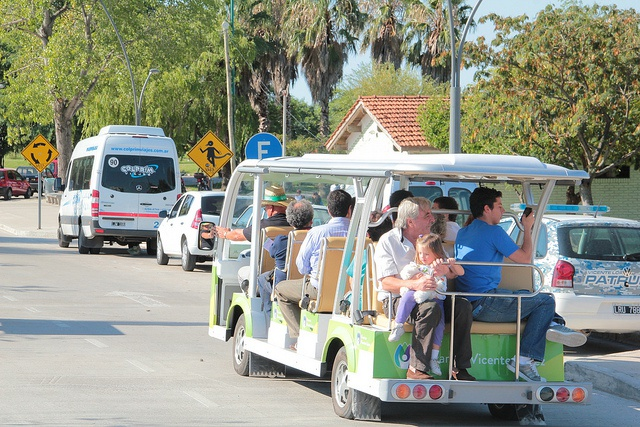Describe the objects in this image and their specific colors. I can see truck in darkgreen, lightblue, white, black, and gray tones, car in darkgreen, darkgray, lightgray, teal, and gray tones, people in darkgreen, blue, navy, and black tones, people in darkgreen, black, lightgray, brown, and darkgray tones, and car in darkgreen, white, gray, darkgray, and black tones in this image. 